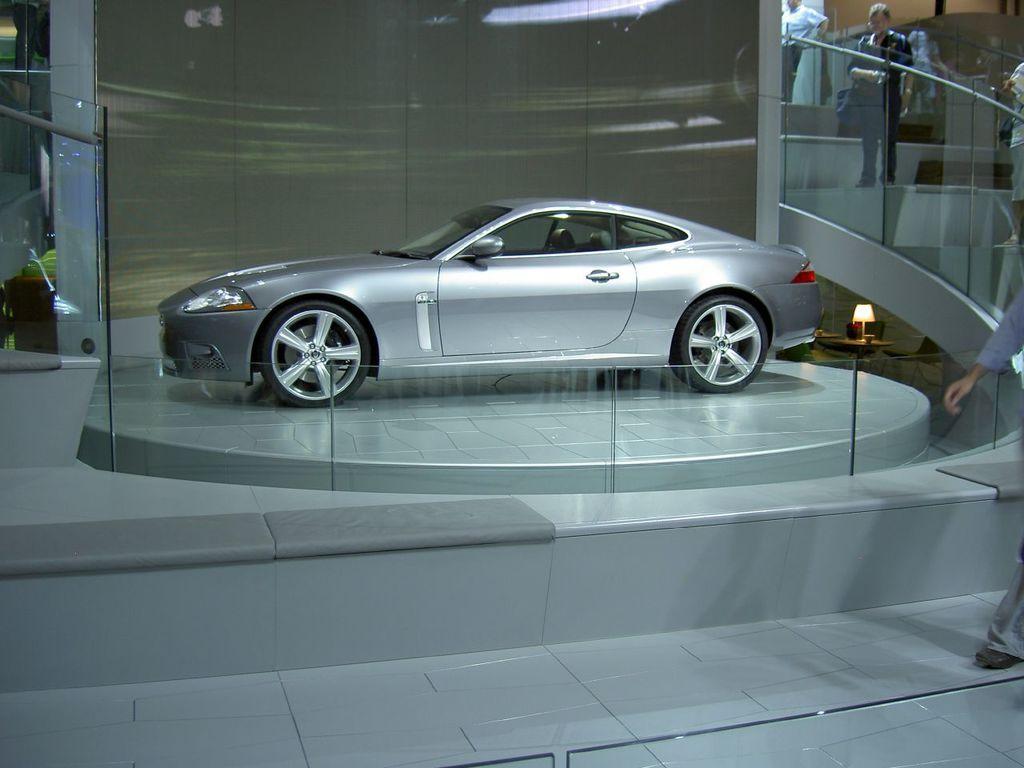Describe this image in one or two sentences. In the foreground I can see a car on the floor, fence and a group of people on the steps. In the background I can see a wall. This image is taken may be in a showroom. 